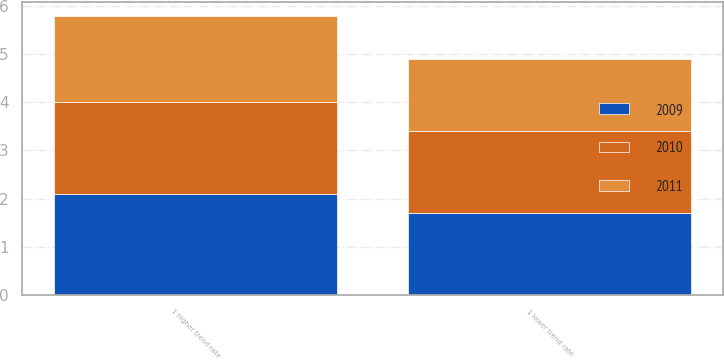<chart> <loc_0><loc_0><loc_500><loc_500><stacked_bar_chart><ecel><fcel>1 higher trend rate<fcel>1 lower trend rate<nl><fcel>2010<fcel>1.9<fcel>1.7<nl><fcel>2011<fcel>1.8<fcel>1.5<nl><fcel>2009<fcel>2.1<fcel>1.7<nl></chart> 